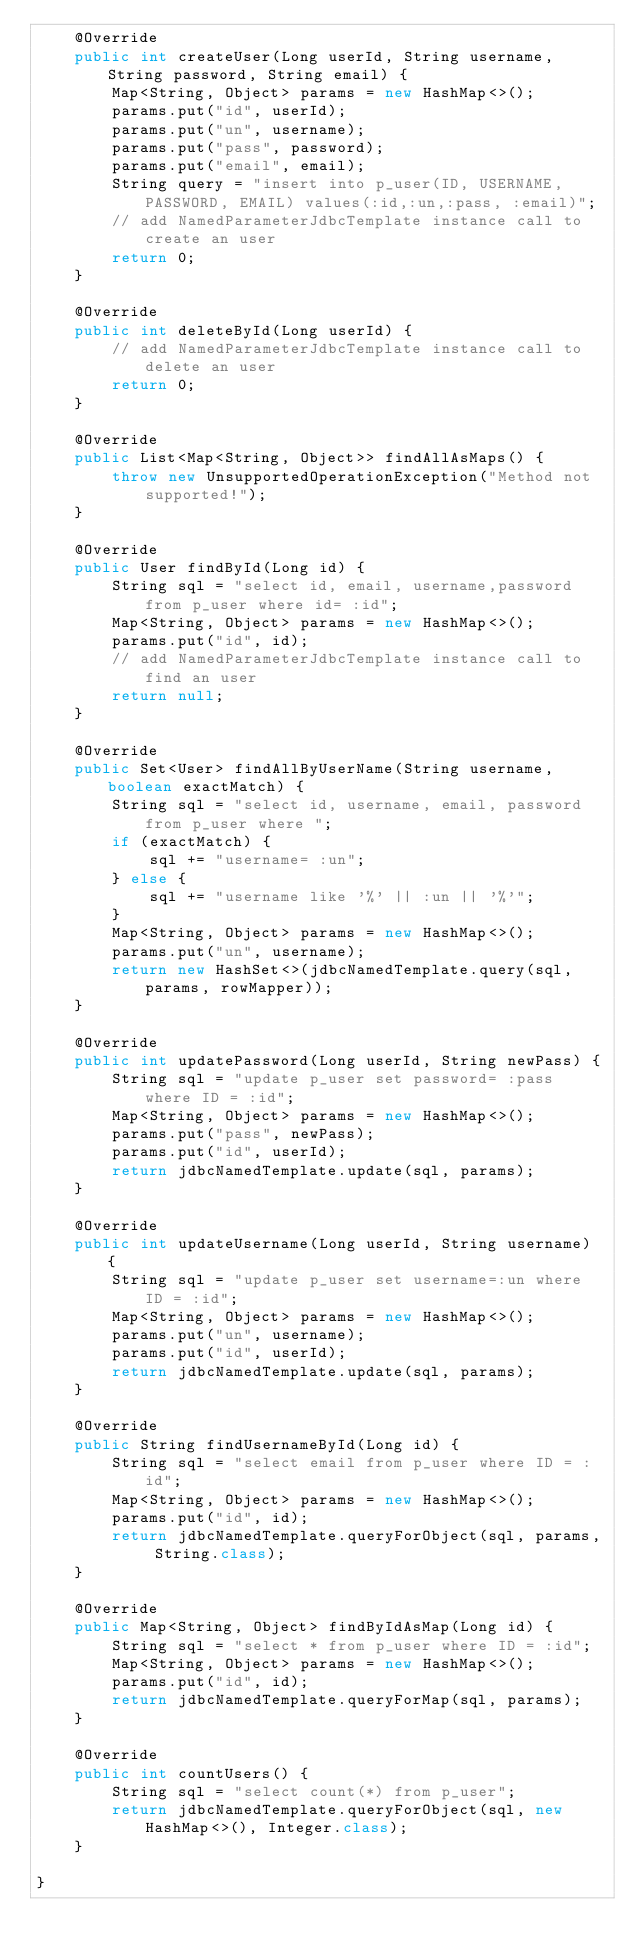<code> <loc_0><loc_0><loc_500><loc_500><_Java_>    @Override
    public int createUser(Long userId, String username, String password, String email) {
        Map<String, Object> params = new HashMap<>();
        params.put("id", userId);
        params.put("un", username);
        params.put("pass", password);
        params.put("email", email);
        String query = "insert into p_user(ID, USERNAME, PASSWORD, EMAIL) values(:id,:un,:pass, :email)";
        // add NamedParameterJdbcTemplate instance call to create an user
        return 0;
    }

    @Override
    public int deleteById(Long userId) {
        // add NamedParameterJdbcTemplate instance call to delete an user
        return 0;
    }

    @Override
    public List<Map<String, Object>> findAllAsMaps() {
        throw new UnsupportedOperationException("Method not supported!");
    }

    @Override
    public User findById(Long id) {
        String sql = "select id, email, username,password from p_user where id= :id";
        Map<String, Object> params = new HashMap<>();
        params.put("id", id);
        // add NamedParameterJdbcTemplate instance call to find an user
        return null;
    }

    @Override
    public Set<User> findAllByUserName(String username, boolean exactMatch) {
        String sql = "select id, username, email, password from p_user where ";
        if (exactMatch) {
            sql += "username= :un";
        } else {
            sql += "username like '%' || :un || '%'";
        }
        Map<String, Object> params = new HashMap<>();
        params.put("un", username);
        return new HashSet<>(jdbcNamedTemplate.query(sql, params, rowMapper));
    }

    @Override
    public int updatePassword(Long userId, String newPass) {
        String sql = "update p_user set password= :pass where ID = :id";
        Map<String, Object> params = new HashMap<>();
        params.put("pass", newPass);
        params.put("id", userId);
        return jdbcNamedTemplate.update(sql, params);
    }

    @Override
    public int updateUsername(Long userId, String username) {
        String sql = "update p_user set username=:un where ID = :id";
        Map<String, Object> params = new HashMap<>();
        params.put("un", username);
        params.put("id", userId);
        return jdbcNamedTemplate.update(sql, params);
    }

    @Override
    public String findUsernameById(Long id) {
        String sql = "select email from p_user where ID = :id";
        Map<String, Object> params = new HashMap<>();
        params.put("id", id);
        return jdbcNamedTemplate.queryForObject(sql, params, String.class);
    }

    @Override
    public Map<String, Object> findByIdAsMap(Long id) {
        String sql = "select * from p_user where ID = :id";
        Map<String, Object> params = new HashMap<>();
        params.put("id", id);
        return jdbcNamedTemplate.queryForMap(sql, params);
    }

    @Override
    public int countUsers() {
        String sql = "select count(*) from p_user";
        return jdbcNamedTemplate.queryForObject(sql, new HashMap<>(), Integer.class);
    }

}
</code> 